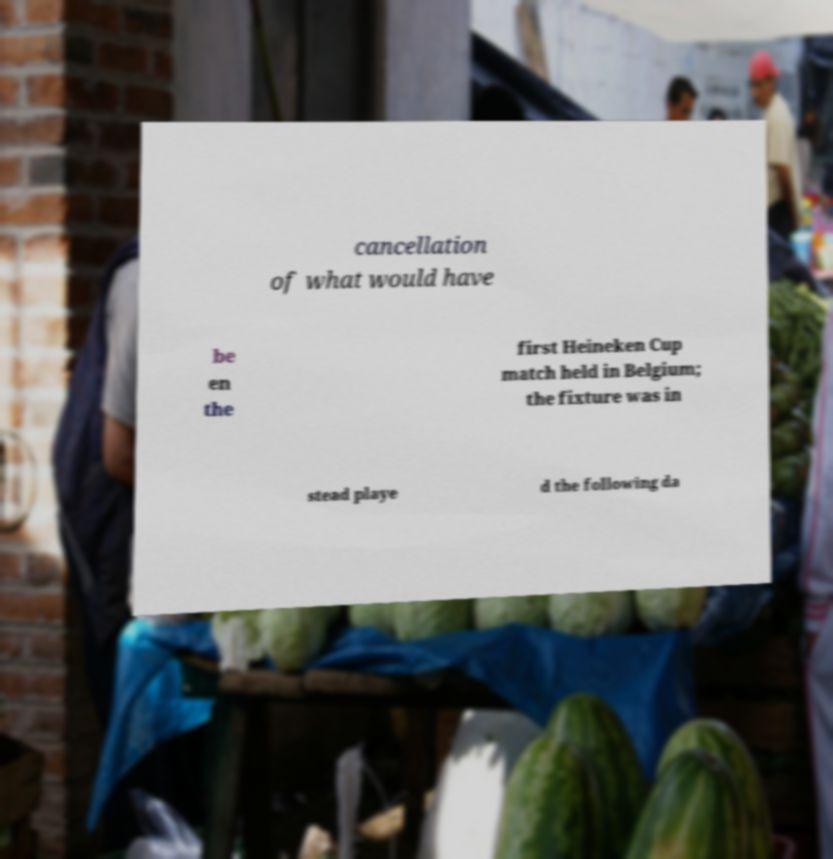For documentation purposes, I need the text within this image transcribed. Could you provide that? cancellation of what would have be en the first Heineken Cup match held in Belgium; the fixture was in stead playe d the following da 